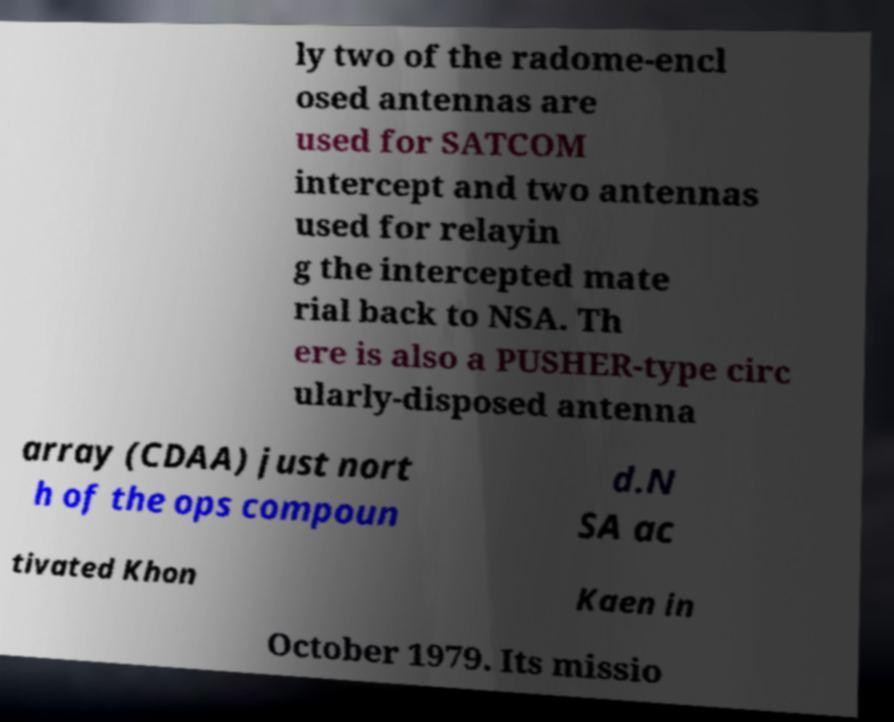Could you extract and type out the text from this image? ly two of the radome-encl osed antennas are used for SATCOM intercept and two antennas used for relayin g the intercepted mate rial back to NSA. Th ere is also a PUSHER-type circ ularly-disposed antenna array (CDAA) just nort h of the ops compoun d.N SA ac tivated Khon Kaen in October 1979. Its missio 